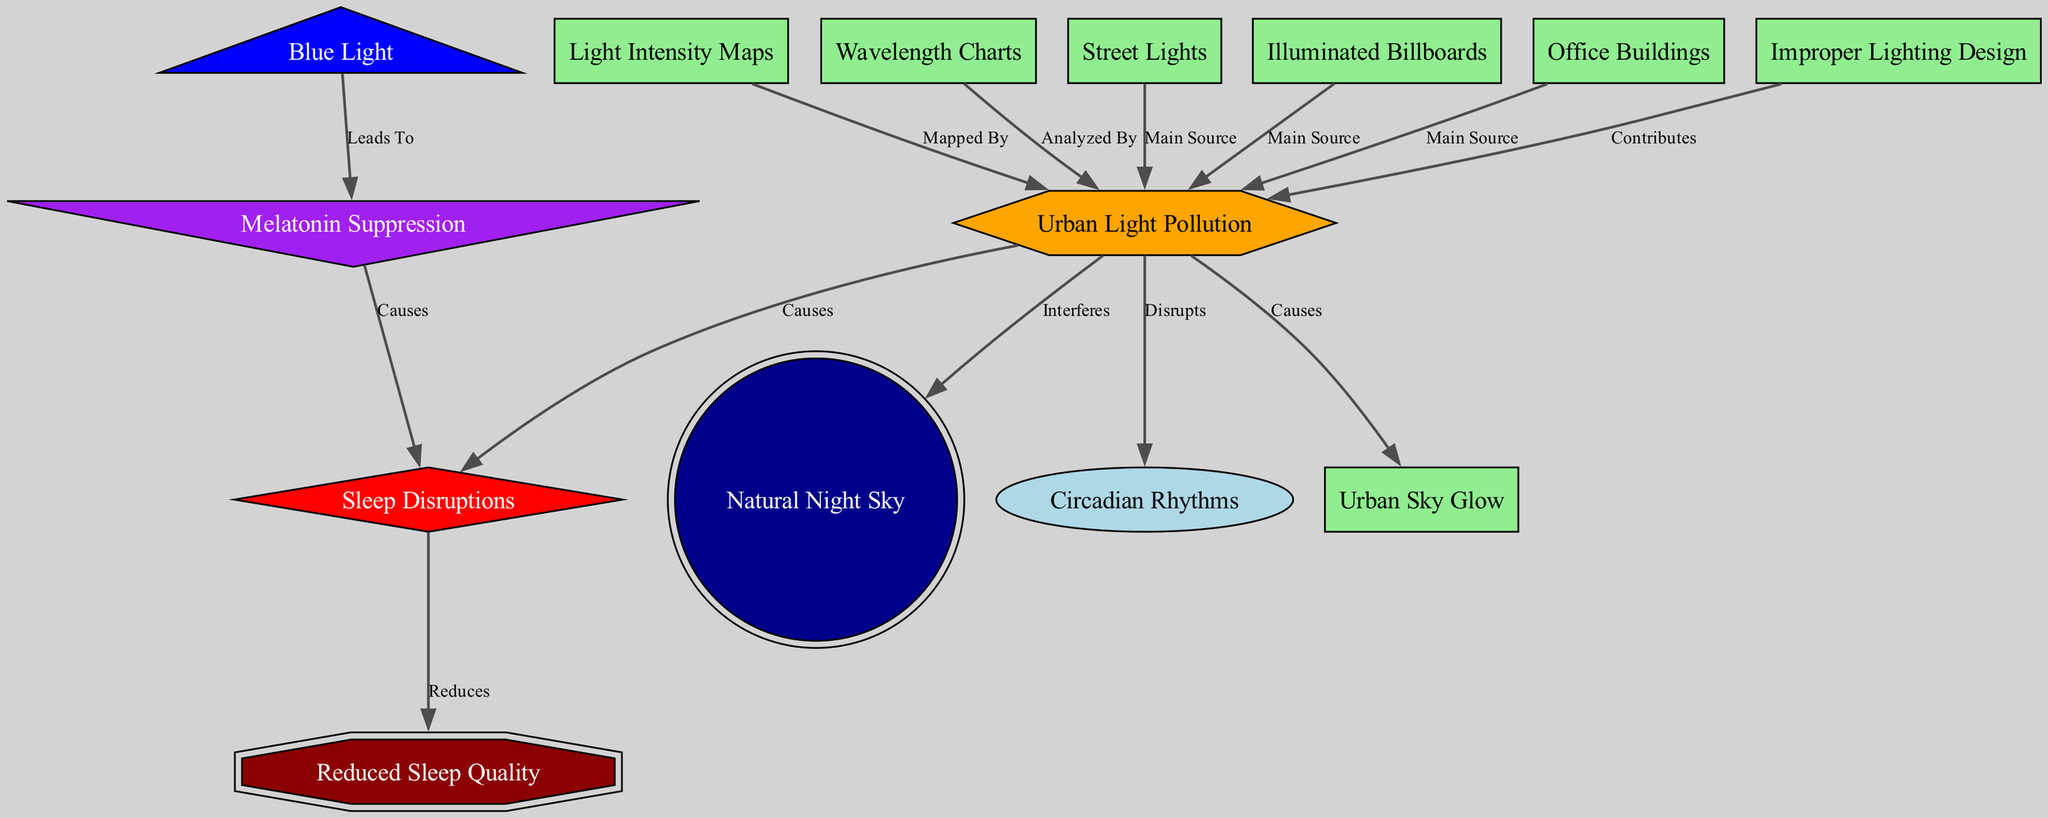What is the main source of urban light pollution? Referring to the nodes and edges in the diagram, “Street Lights,” “Billboards,” and “Office Buildings” are all identified as main sources contributing to “Urban Light Pollution.”
Answer: Street Lights, Billboards, Office Buildings How many nodes are there in the diagram? Counting the distinct nodes listed in the data section reveals there are 13 unique nodes present in the diagram related to light pollution and sleep quality.
Answer: 13 Which node represents the concept that urban light pollution disrupts sleep? The edge labeled “Causes” from “Urban Light Pollution” points directly to the node “Sleep Disruptions,” indicating this relationship.
Answer: Sleep Disruptions What effect does blue light have on melatonin? The node labeled “Blue Light” has an edge leading to “Melatonin Suppression,” which signifies it leads to that outcome, explaining the connection.
Answer: Leads To Explain how urban light pollution affects sleep quality. Following the flow in the diagram, "Urban Light Pollution" disrupts "Circadian Rhythms," which then leads to "Sleep Disruptions." The edge from "Sleep Disruptions" to "Sleep Quality" states that these disruptions reduce sleep quality. Therefore, the pathway indicates that urban light pollution ultimately results in reduced sleep quality.
Answer: Reduced Sleep Quality What implications does improper lighting have? The edge indicates that “Improper Lighting” contributes to “Urban Light Pollution.” This shows it plays a role in exacerbating light pollution, which in turn affects various aspects related to sleep.
Answer: Contributes How does urban light pollution affect the natural night sky? There is a direct edge labeled “Interferes” from “Urban Light Pollution” to “Natural Night Sky,” demonstrating how urban light sources disrupt the visibility of natural celestial phenomena.
Answer: Interferes What is shown by light intensity maps about urban light pollution? The diagram depicts that “Light Intensity Maps” are used to analyze and map “Urban Light Pollution,” illustrating the correlation between intensity levels and pollution presence.
Answer: Mapped By Is there any node that connects to circadian rhythms? The node “Circadian Rhythms” is interconnected through an edge from “Urban Light Pollution.” This indicates that urban light pollution has a direct impact on circadian rhythms.
Answer: Urban Light Pollution 